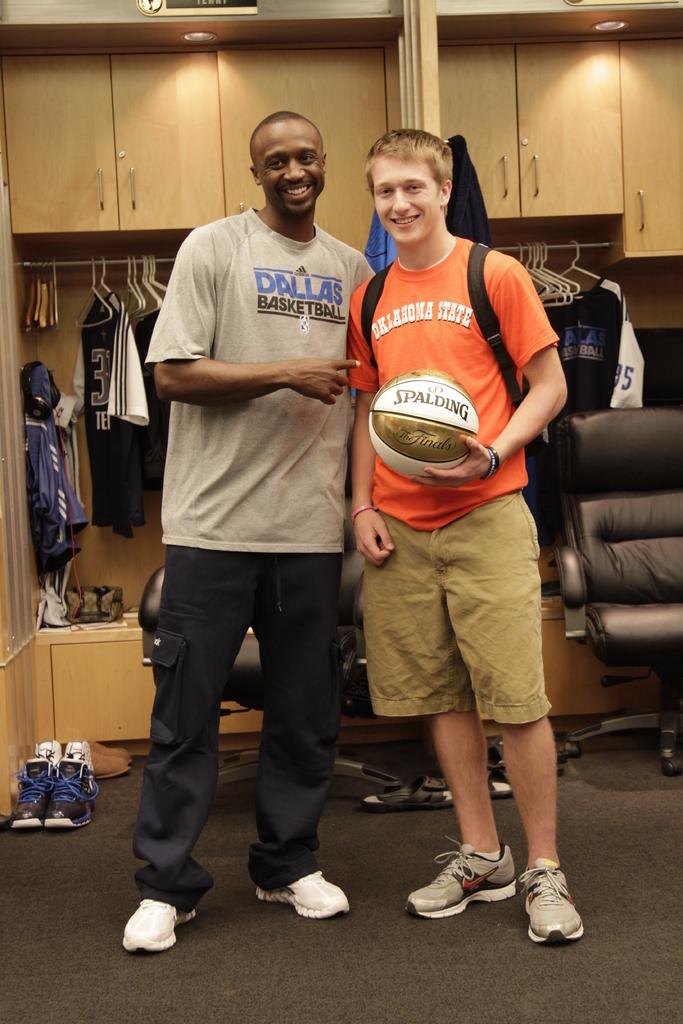What is the name on the ball?
Make the answer very short. Spalding. What team does the taller gentlemen play for according to his shirt?
Make the answer very short. Dallas. 